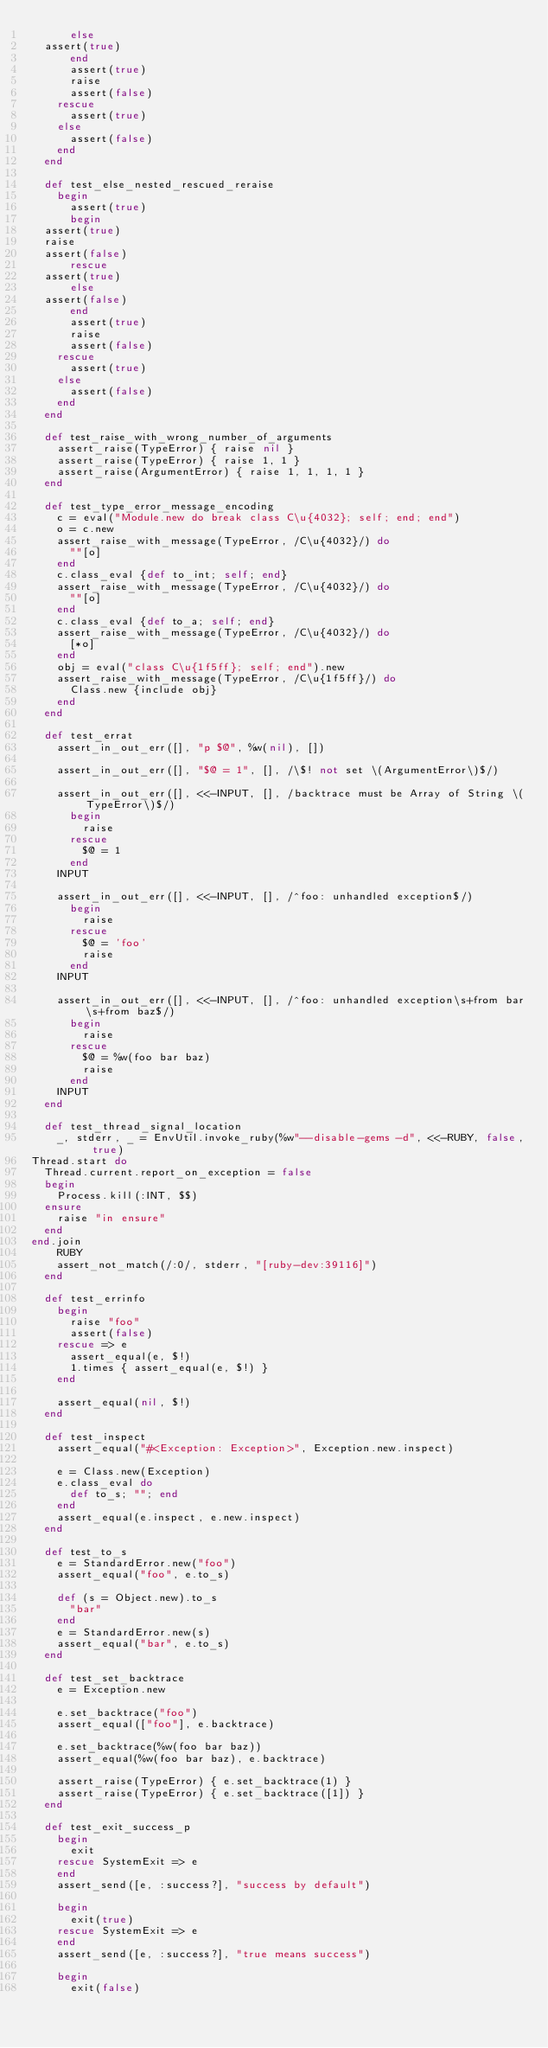Convert code to text. <code><loc_0><loc_0><loc_500><loc_500><_Ruby_>      else
	assert(true)
      end
      assert(true)
      raise
      assert(false)
    rescue
      assert(true)
    else
      assert(false)
    end
  end

  def test_else_nested_rescued_reraise
    begin
      assert(true)
      begin
	assert(true)
	raise
	assert(false)
      rescue
	assert(true)
      else
	assert(false)
      end
      assert(true)
      raise
      assert(false)
    rescue
      assert(true)
    else
      assert(false)
    end
  end

  def test_raise_with_wrong_number_of_arguments
    assert_raise(TypeError) { raise nil }
    assert_raise(TypeError) { raise 1, 1 }
    assert_raise(ArgumentError) { raise 1, 1, 1, 1 }
  end

  def test_type_error_message_encoding
    c = eval("Module.new do break class C\u{4032}; self; end; end")
    o = c.new
    assert_raise_with_message(TypeError, /C\u{4032}/) do
      ""[o]
    end
    c.class_eval {def to_int; self; end}
    assert_raise_with_message(TypeError, /C\u{4032}/) do
      ""[o]
    end
    c.class_eval {def to_a; self; end}
    assert_raise_with_message(TypeError, /C\u{4032}/) do
      [*o]
    end
    obj = eval("class C\u{1f5ff}; self; end").new
    assert_raise_with_message(TypeError, /C\u{1f5ff}/) do
      Class.new {include obj}
    end
  end

  def test_errat
    assert_in_out_err([], "p $@", %w(nil), [])

    assert_in_out_err([], "$@ = 1", [], /\$! not set \(ArgumentError\)$/)

    assert_in_out_err([], <<-INPUT, [], /backtrace must be Array of String \(TypeError\)$/)
      begin
        raise
      rescue
        $@ = 1
      end
    INPUT

    assert_in_out_err([], <<-INPUT, [], /^foo: unhandled exception$/)
      begin
        raise
      rescue
        $@ = 'foo'
        raise
      end
    INPUT

    assert_in_out_err([], <<-INPUT, [], /^foo: unhandled exception\s+from bar\s+from baz$/)
      begin
        raise
      rescue
        $@ = %w(foo bar baz)
        raise
      end
    INPUT
  end

  def test_thread_signal_location
    _, stderr, _ = EnvUtil.invoke_ruby(%w"--disable-gems -d", <<-RUBY, false, true)
Thread.start do
  Thread.current.report_on_exception = false
  begin
    Process.kill(:INT, $$)
  ensure
    raise "in ensure"
  end
end.join
    RUBY
    assert_not_match(/:0/, stderr, "[ruby-dev:39116]")
  end

  def test_errinfo
    begin
      raise "foo"
      assert(false)
    rescue => e
      assert_equal(e, $!)
      1.times { assert_equal(e, $!) }
    end

    assert_equal(nil, $!)
  end

  def test_inspect
    assert_equal("#<Exception: Exception>", Exception.new.inspect)

    e = Class.new(Exception)
    e.class_eval do
      def to_s; ""; end
    end
    assert_equal(e.inspect, e.new.inspect)
  end

  def test_to_s
    e = StandardError.new("foo")
    assert_equal("foo", e.to_s)

    def (s = Object.new).to_s
      "bar"
    end
    e = StandardError.new(s)
    assert_equal("bar", e.to_s)
  end

  def test_set_backtrace
    e = Exception.new

    e.set_backtrace("foo")
    assert_equal(["foo"], e.backtrace)

    e.set_backtrace(%w(foo bar baz))
    assert_equal(%w(foo bar baz), e.backtrace)

    assert_raise(TypeError) { e.set_backtrace(1) }
    assert_raise(TypeError) { e.set_backtrace([1]) }
  end

  def test_exit_success_p
    begin
      exit
    rescue SystemExit => e
    end
    assert_send([e, :success?], "success by default")

    begin
      exit(true)
    rescue SystemExit => e
    end
    assert_send([e, :success?], "true means success")

    begin
      exit(false)</code> 